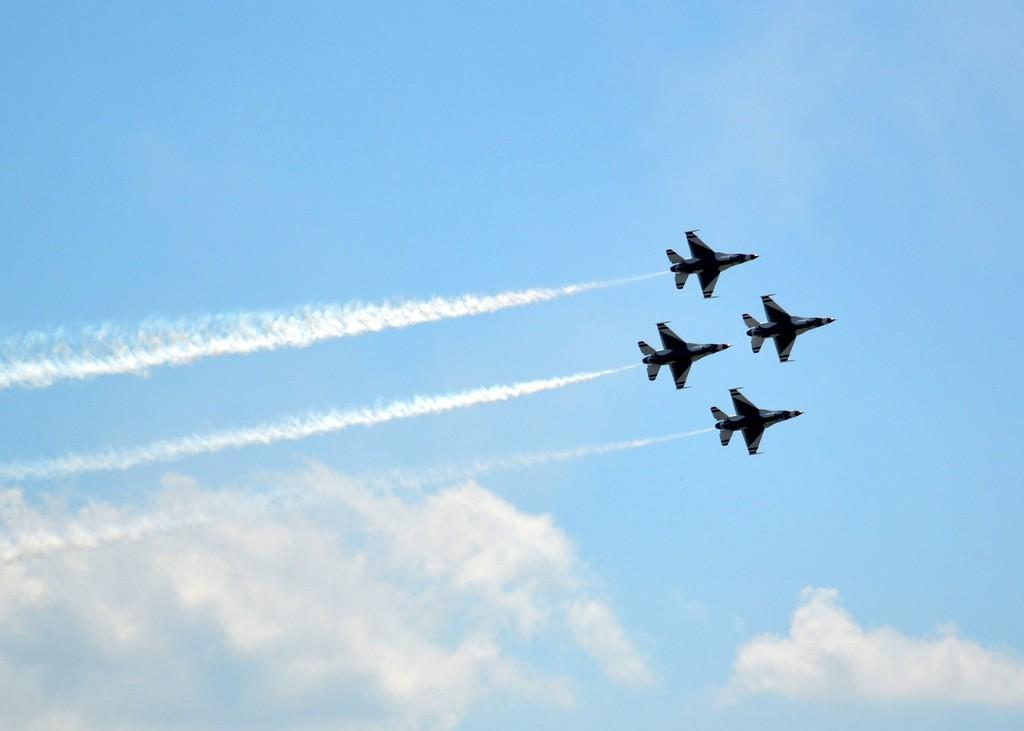How would you summarize this image in a sentence or two? In this image we can see airplanes flying in the sky. 